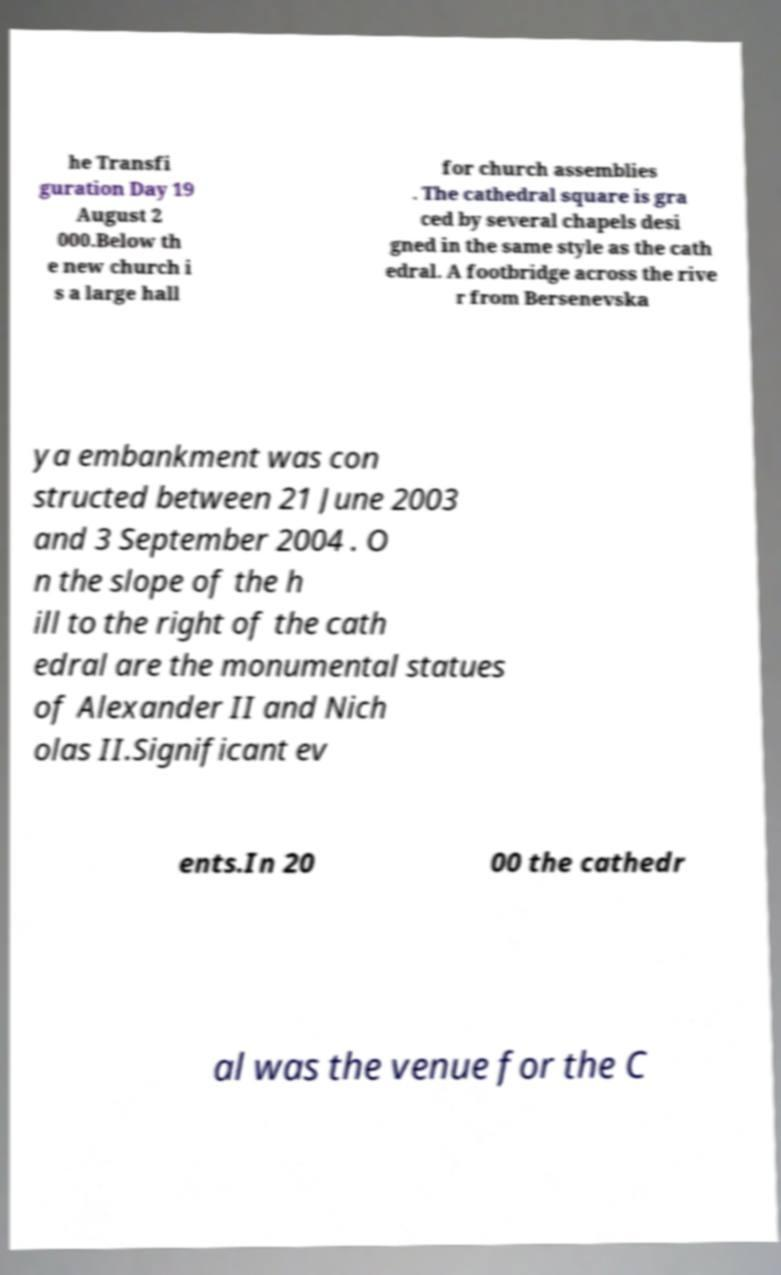Please identify and transcribe the text found in this image. he Transfi guration Day 19 August 2 000.Below th e new church i s a large hall for church assemblies . The cathedral square is gra ced by several chapels desi gned in the same style as the cath edral. A footbridge across the rive r from Bersenevska ya embankment was con structed between 21 June 2003 and 3 September 2004 . O n the slope of the h ill to the right of the cath edral are the monumental statues of Alexander II and Nich olas II.Significant ev ents.In 20 00 the cathedr al was the venue for the C 